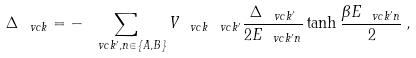<formula> <loc_0><loc_0><loc_500><loc_500>\Delta _ { \ v c k } = - \sum _ { \ v c k ^ { \prime } , n \in \{ A , B \} } V _ { \ v c k \ v c k ^ { \prime } } \frac { \Delta _ { \ v c k ^ { \prime } } } { 2 E _ { \ v c k ^ { \prime } n } } \tanh \frac { \beta E _ { \ v c k ^ { \prime } n } } 2 \, ,</formula> 